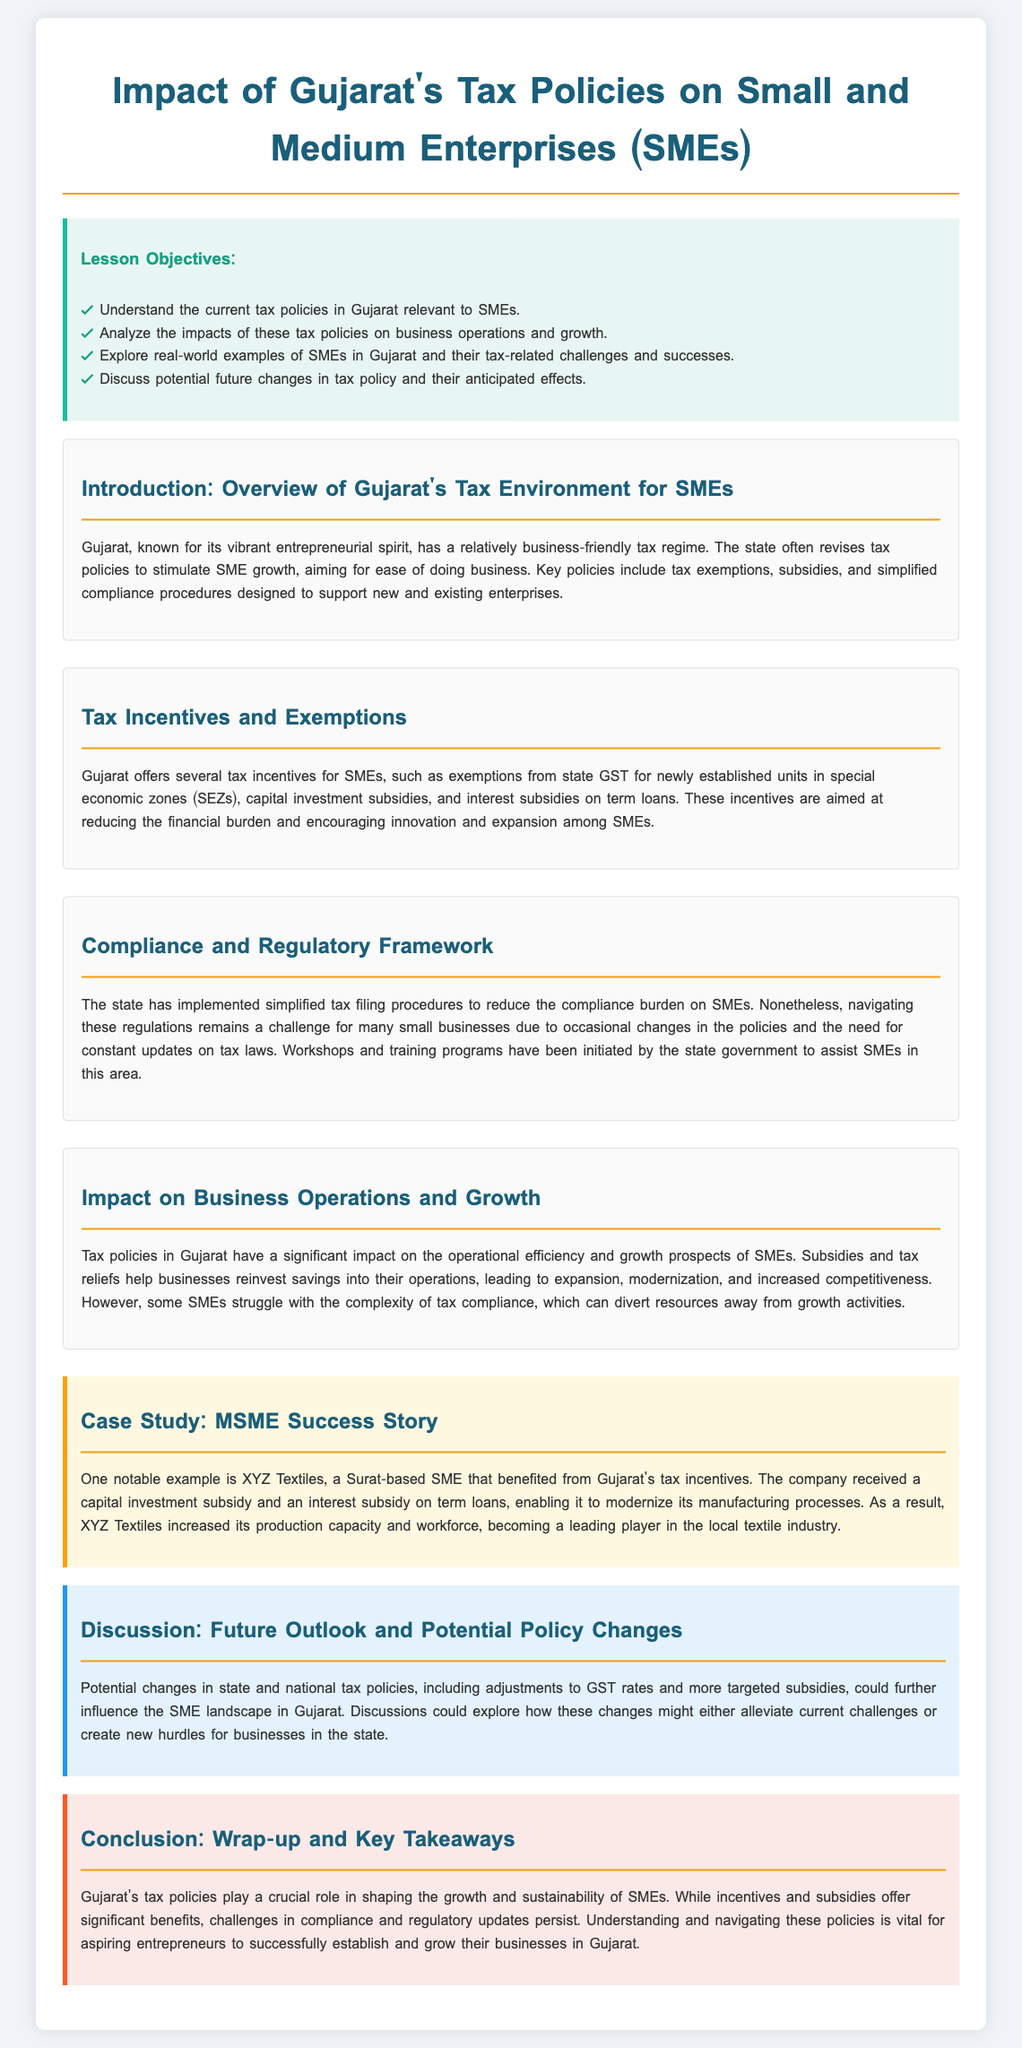What are the lesson objectives? The document outlines specific goals for the lesson on tax policies and SMEs, including understanding current tax policies and analyzing impacts.
Answer: Understand the current tax policies in Gujarat relevant to SMEs, Analyze the impacts of these tax policies on business operations and growth, Explore real-world examples of SMEs in Gujarat and their tax-related challenges and successes, Discuss potential future changes in tax policy and their anticipated effects What tax exemptions are mentioned for SMEs in Gujarat? The document specifies tax exemptions for newly established units in special economic zones, which represents a vital incentive for SMEs in Gujarat.
Answer: Exemptions from state GST for newly established units in special economic zones What is a significant challenge SMEs face regarding tax compliance? According to the document, one challenge includes the complexity of tax compliance, which can be a barrier for many SMEs in Gujarat.
Answer: Complexity of tax compliance Which SME success story is highlighted in the case study? The document provides an example of XYZ Textiles, which showcases how the company benefited from Gujarat's tax incentives.
Answer: XYZ Textiles What does the future outlook section mention could influence SME policies? The discussion hints at potential changes in state and national tax policies, indicating a proactive approach towards adapting to future challenges.
Answer: Adjustments to GST rates and more targeted subsidies How do tax policies in Gujarat impact operational efficiency? The document explains that tax policies assist in reinvesting savings into operations, thus enhancing competitiveness for SMEs.
Answer: Help businesses reinvest savings into their operations 